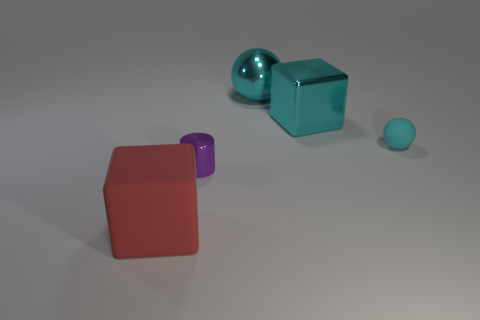What number of spheres are there?
Offer a very short reply. 2. What number of green things are shiny cylinders or rubber objects?
Provide a succinct answer. 0. What number of other objects are there of the same shape as the large red rubber thing?
Keep it short and to the point. 1. Does the block behind the red thing have the same color as the cube left of the large metallic ball?
Ensure brevity in your answer.  No. How many tiny things are brown metal blocks or purple cylinders?
Give a very brief answer. 1. What size is the metal thing that is the same shape as the big matte thing?
Provide a succinct answer. Large. Is there anything else that is the same size as the red rubber block?
Provide a succinct answer. Yes. What material is the cube behind the block that is to the left of the large cyan sphere?
Offer a terse response. Metal. What number of metallic objects are either tiny purple objects or big cubes?
Your answer should be very brief. 2. There is a big shiny thing that is the same shape as the large rubber thing; what color is it?
Your answer should be very brief. Cyan. 